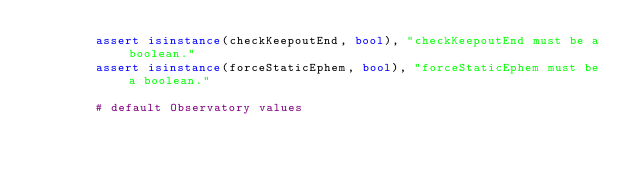Convert code to text. <code><loc_0><loc_0><loc_500><loc_500><_Python_>        assert isinstance(checkKeepoutEnd, bool), "checkKeepoutEnd must be a boolean."
        assert isinstance(forceStaticEphem, bool), "forceStaticEphem must be a boolean."
        
        # default Observatory values</code> 